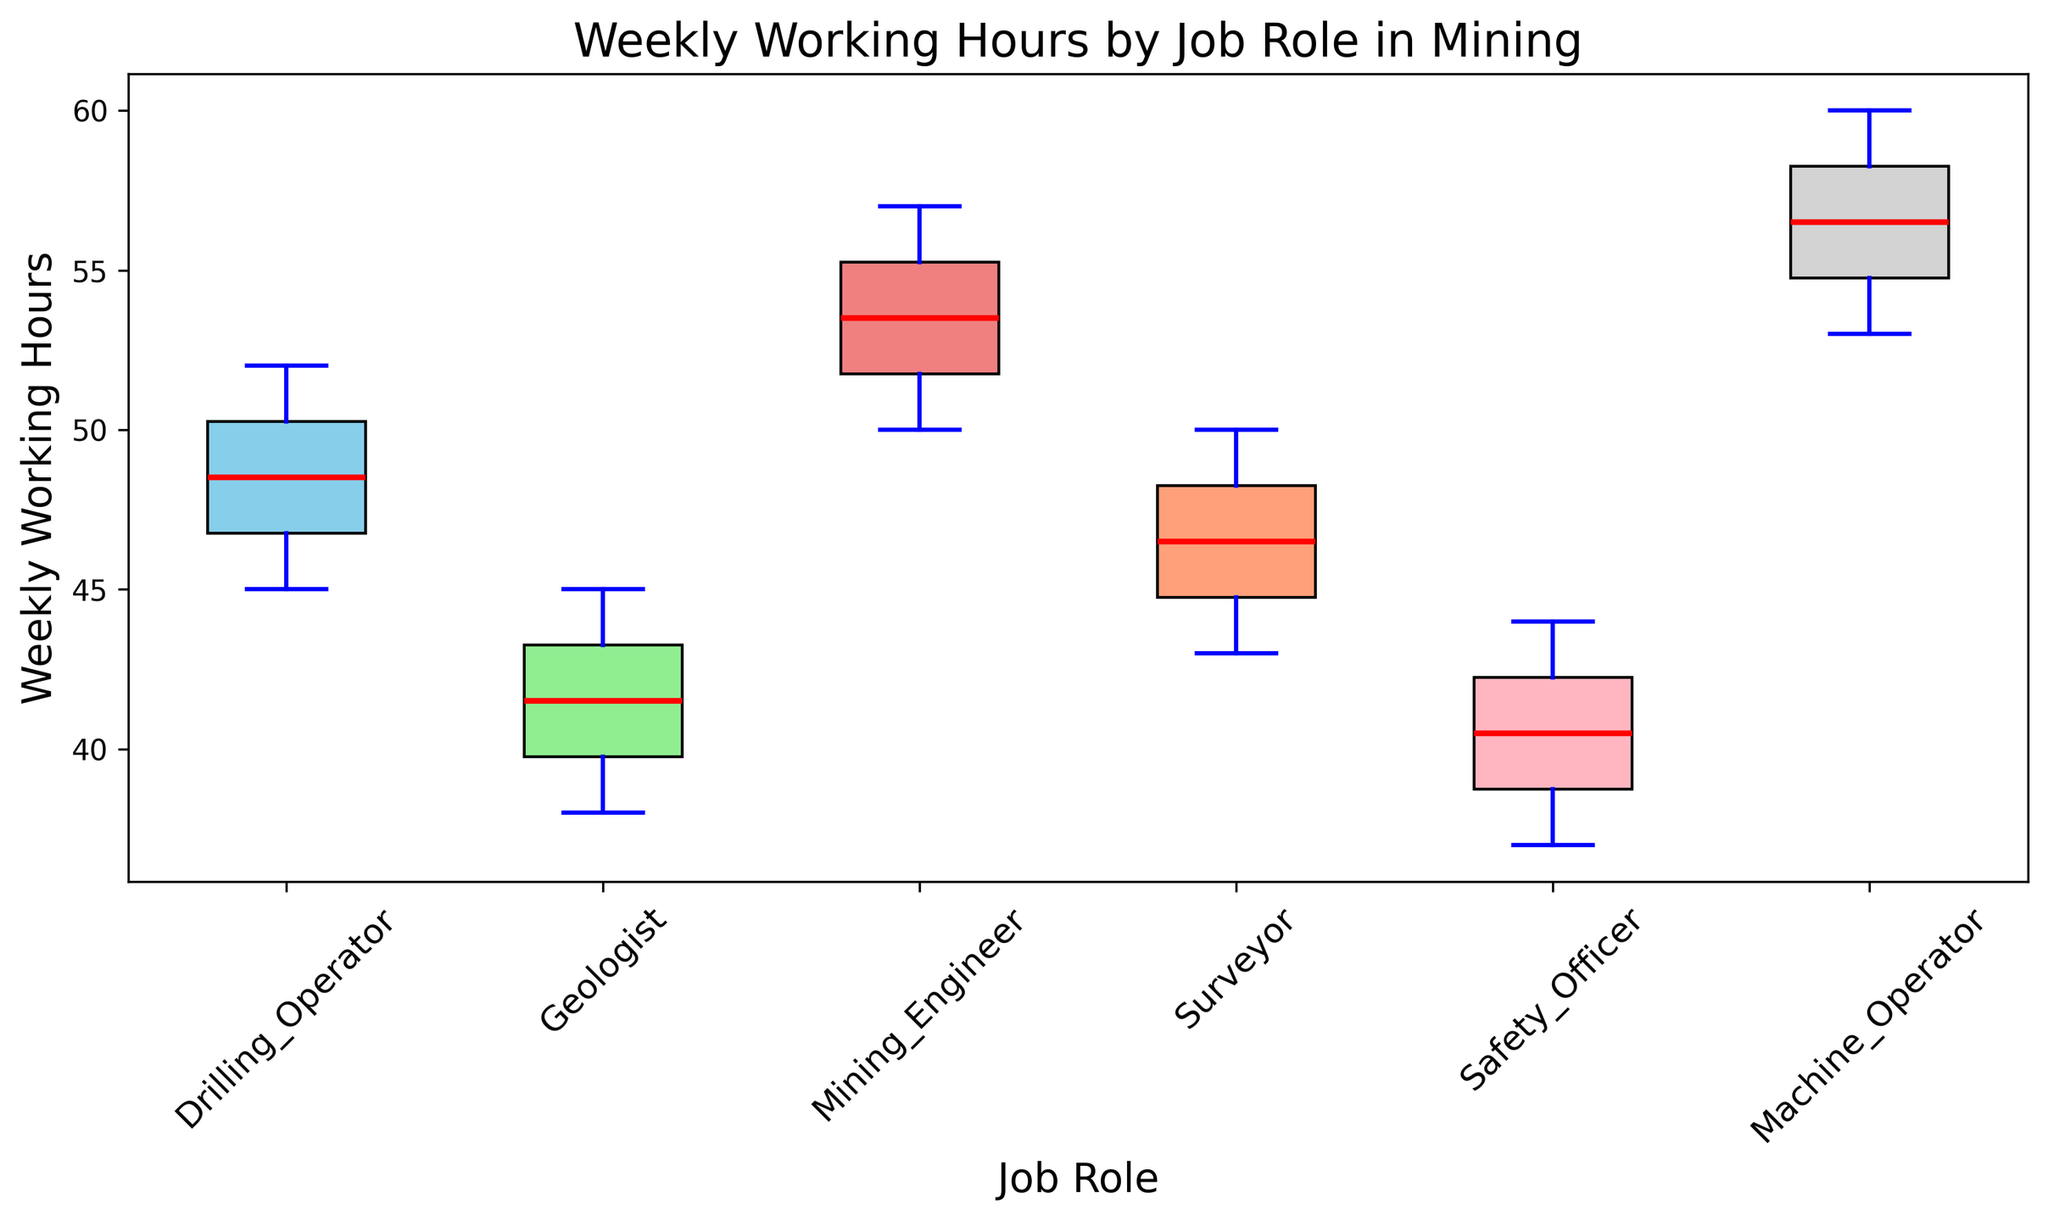What is the median weekly work hours for Drilling Operators? To find the median, look for the middle value in the box plot for Drilling Operators. The line inside the box for Drilling Operators represents the median.
Answer: 48 Which job role works the most hours on average per week? Compare the median lines of all job roles; the highest median represents the job role that works the most hours on average. The box plot for Machine Operators has the highest median line.
Answer: Machine Operators What is the range of weekly work hours for Geologists? The range is the difference between the maximum and minimum whiskers of the box plot for Geologists. The maximum whisker (top) is 45 and the minimum whisker (bottom) is 38. So the range is 45 - 38.
Answer: 7 Which job role has the smallest interquartile range (IQR) of weekly work hours? IQR is represented by the length of the box. Compare the length of the boxes for all job roles. Safety Officers have the smallest box, hence the smallest IQR.
Answer: Safety Officers How do the weekly work hours of Surveyors compare to those of Drilling Operators? Compare the median lines. The median for Surveyors is lower at 46.5, while the median for Drilling Operators is 48. Therefore, Surveyors work fewer hours on average.
Answer: Surveyors work fewer hours What is the maximum weekly work hours for Machine Operators, and how does it compare to the maximum for Mining Engineers? Look at the top whisker for both Machine Operators and Mining Engineers. Machine Operators have a maximum of 60 hours, while Mining Engineers have 57 hours.
Answer: Machine Operators work 3 more hours Are there any job roles with outliers in weekly work hours? Outliers are represented by points outside the whiskers in the box plot. There are no points outside the whiskers for any job role, indicating no outliers.
Answer: No Which job role has the most consistent weekly work hours? Consistency is indicated by the smallest range. Compare the length between the whiskers for each job role. Safety Officers have the most consistent weekly work hours with the smallest range.
Answer: Safety Officers Is the median weekly work hours for Safety Officers greater than the first quartile (Q1) weekly work hours for Mining Engineers? Compare the median line of Safety Officers with the lower edge of the box (Q1) for Mining Engineers. The median for Safety Officers is 41.5 and the Q1 for Mining Engineers is above this point.
Answer: No What is the interquartile range (IQR) for Mining Engineers' weekly work hours? The IQR is the difference between the upper quartile (Q3) and the lower quartile (Q1). For Mining Engineers, the upper quartile (top of the box) is around 55 and the lower quartile (bottom of the box) is around 51, so IQR is 55 - 51.
Answer: 4 